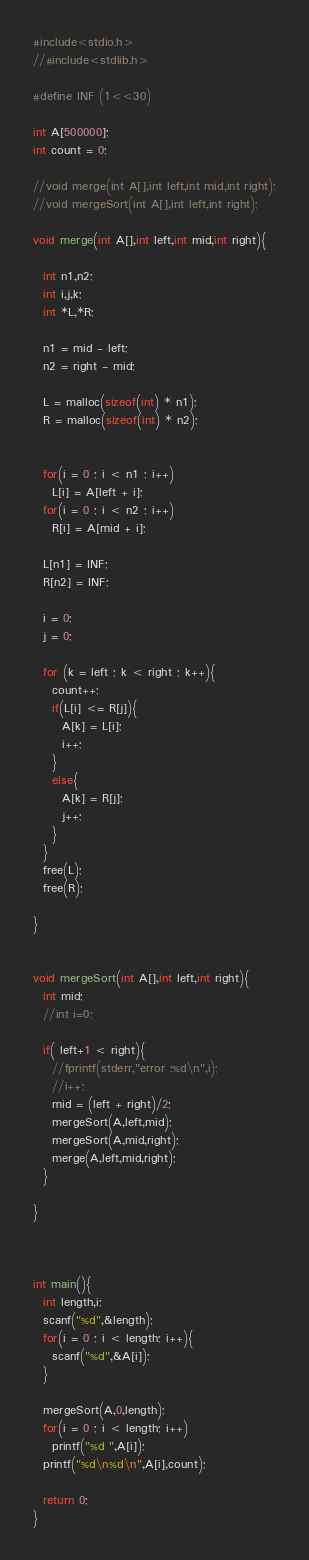Convert code to text. <code><loc_0><loc_0><loc_500><loc_500><_C_>#include<stdio.h>
//#include<stdlib.h>

#define INF (1<<30)

int A[500000];
int count = 0;

//void merge(int A[],int left,int mid,int right);
//void mergeSort(int A[],int left,int right);

void merge(int A[],int left,int mid,int right){

  int n1,n2;
  int i,j,k;
  int *L,*R;

  n1 = mid - left;
  n2 = right - mid;
  
  L = malloc(sizeof(int) * n1);
  R = malloc(sizeof(int) * n2);
  
  
  for(i = 0 ; i < n1 ; i++) 
    L[i] = A[left + i]; 
  for(i = 0 ; i < n2 ; i++)
    R[i] = A[mid + i];

  L[n1] = INF;
  R[n2] = INF;

  i = 0;
  j = 0;

  for (k = left ; k < right ; k++){
    count++;
    if(L[i] <= R[j]){
      A[k] = L[i];
      i++;
    }
    else{
      A[k] = R[j];
      j++;
    }
  }
  free(L);
  free(R);

}


void mergeSort(int A[],int left,int right){
  int mid;
  //int i=0;

  if( left+1 < right){
    //fprintf(stderr,"error :%d\n",i);
    //i++;
    mid = (left + right)/2;
    mergeSort(A,left,mid);
    mergeSort(A,mid,right);
    merge(A,left,mid,right);
  }

}



int main(){
  int length,i;
  scanf("%d",&length);
  for(i = 0 ; i < length; i++){
    scanf("%d",&A[i]);
  }

  mergeSort(A,0,length);
  for(i = 0 ; i < length; i++)
    printf("%d ",A[i]);
  printf("%d\n%d\n",A[i],count);

  return 0;
}</code> 